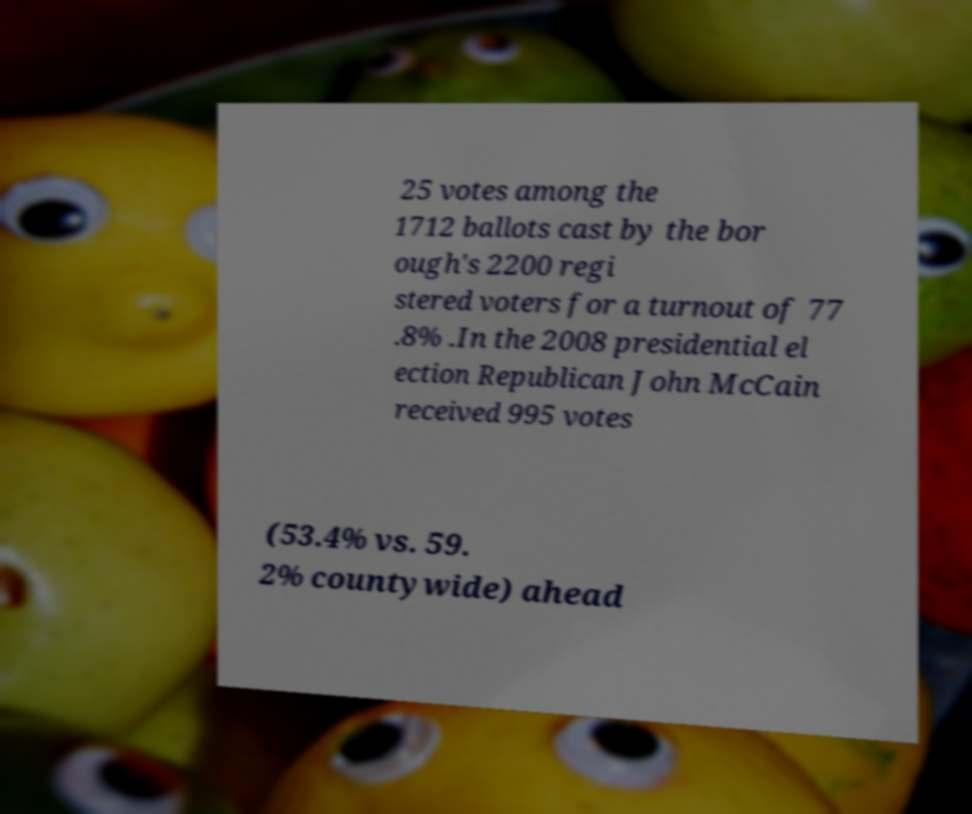Can you accurately transcribe the text from the provided image for me? 25 votes among the 1712 ballots cast by the bor ough's 2200 regi stered voters for a turnout of 77 .8% .In the 2008 presidential el ection Republican John McCain received 995 votes (53.4% vs. 59. 2% countywide) ahead 